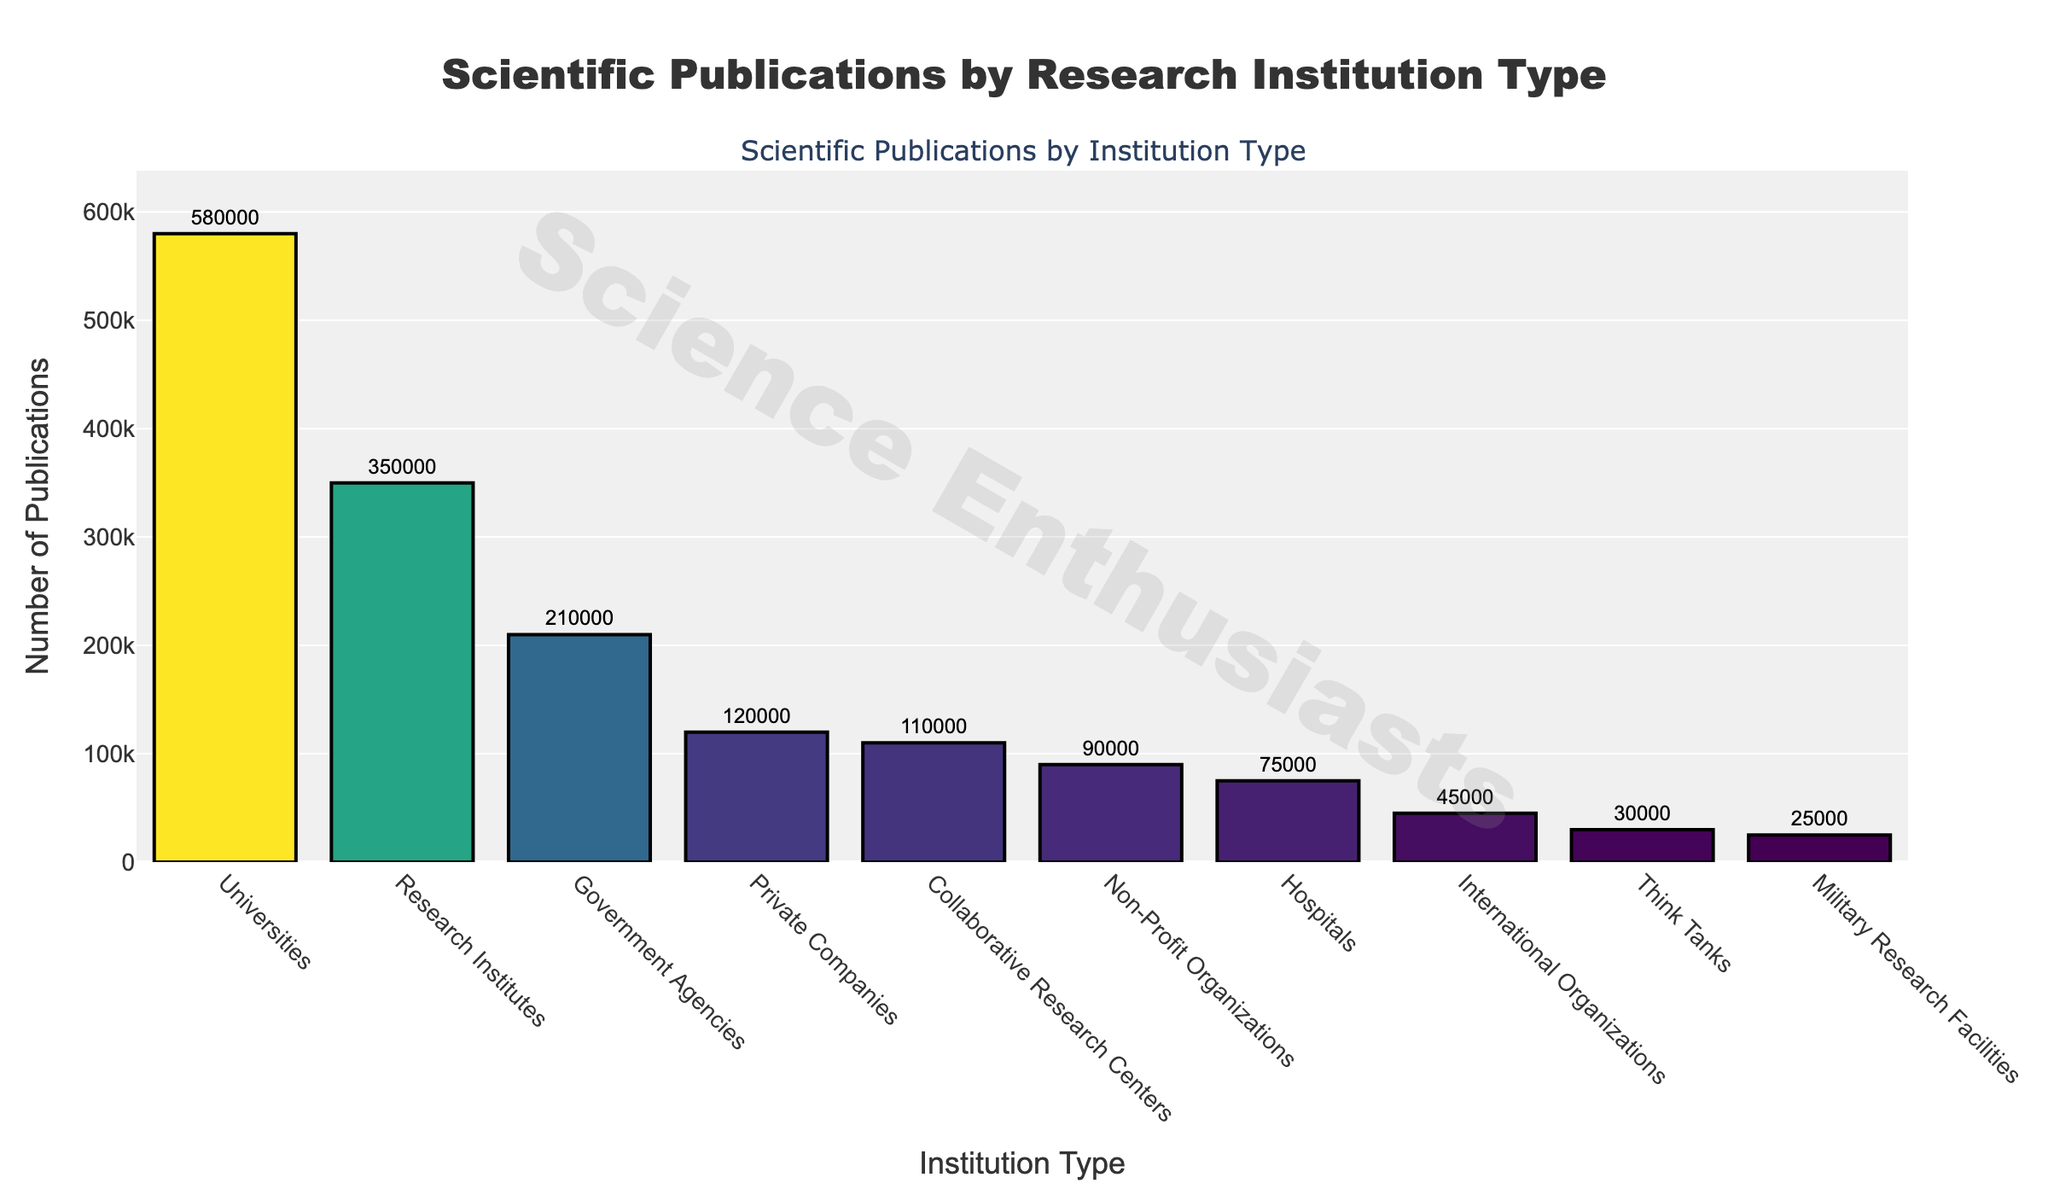Which institution type has the highest number of scientific publications? The bar chart shows the number of publications for each institution type. The bar with the highest value represents universities.
Answer: Universities Which institution type has the lowest number of scientific publications? By looking at the shortest bar in the chart, International Organizations have the lowest number of scientific publications.
Answer: International Organizations What is the total number of publications from universities and government agencies combined? The chart shows universities with 580,000 publications and government agencies with 210,000 publications. Adding these together: 580,000 + 210,000 = 790,000.
Answer: 790,000 How many more publications do Research Institutes have compared to Private Companies? Research Institutes have 350,000 publications and Private Companies have 120,000 publications. The difference is: 350,000 - 120,000 = 230,000.
Answer: 230,000 What is the average number of publications for Universities, Private Companies, and Government Agencies? The chart shows 580,000 publications for Universities, 120,000 for Private Companies, and 210,000 for Government Agencies. The average is calculated as: (580,000 + 120,000 + 210,000) / 3 = 303,333.33.
Answer: 303,333.33 Is the number of publications from Hospitals greater than the combined number of publications from Military Research Facilities and Think Tanks? Hospitals have 75,000 publications. Combined publications from Military Research Facilities and Think Tanks are: 25,000 + 30,000 = 55,000. Since 75,000 > 55,000, Hospitals have more.
Answer: Yes Rank the following institution types by the number of publications from highest to lowest: Collaborative Research Centers, Non-Profit Organizations, Think Tanks. From the chart, Collaborative Research Centers have 110,000, Non-Profit Organizations have 90,000, and Think Tanks have 30,000 publications. Thus, the ranking is Collaborative Research Centers, Non-Profit Organizations, Think Tanks.
Answer: Collaborative Research Centers, Non-Profit Organizations, Think Tanks What percentage of the total publications is contributed by Private Companies? The total number of publications is the sum of all values: 580,000 + 120,000 + 210,000 + 350,000 + 90,000 + 75,000 + 45,000 + 30,000 + 25,000 + 110,000 = 1,635,000. The percentage by Private Companies is: (120,000 / 1,635,000) * 100 = 7.34%.
Answer: 7.34% What is the difference in the number of publications between the institution type with the second-highest and second-lowest number of publications? Research Institutes have the second-highest number of publications (350,000), and Think Tanks have the second-lowest (30,000). The difference is: 350,000 - 30,000 = 320,000.
Answer: 320,000 